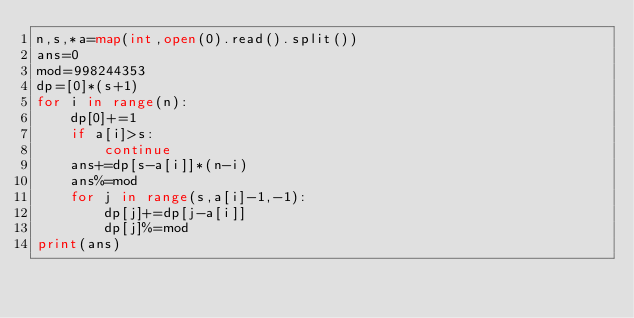<code> <loc_0><loc_0><loc_500><loc_500><_Python_>n,s,*a=map(int,open(0).read().split())
ans=0
mod=998244353
dp=[0]*(s+1)
for i in range(n):
	dp[0]+=1
	if a[i]>s:
		continue
	ans+=dp[s-a[i]]*(n-i)
	ans%=mod
	for j in range(s,a[i]-1,-1):
		dp[j]+=dp[j-a[i]]
		dp[j]%=mod
print(ans)

</code> 